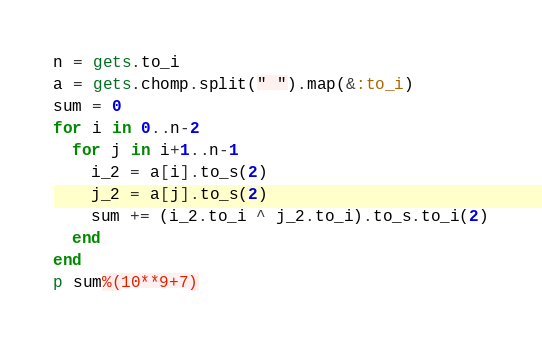<code> <loc_0><loc_0><loc_500><loc_500><_Ruby_>n = gets.to_i
a = gets.chomp.split(" ").map(&:to_i)
sum = 0
for i in 0..n-2
  for j in i+1..n-1
    i_2 = a[i].to_s(2)
    j_2 = a[j].to_s(2)
    sum += (i_2.to_i ^ j_2.to_i).to_s.to_i(2)
  end
end
p sum%(10**9+7)
</code> 